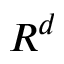Convert formula to latex. <formula><loc_0><loc_0><loc_500><loc_500>R ^ { d }</formula> 